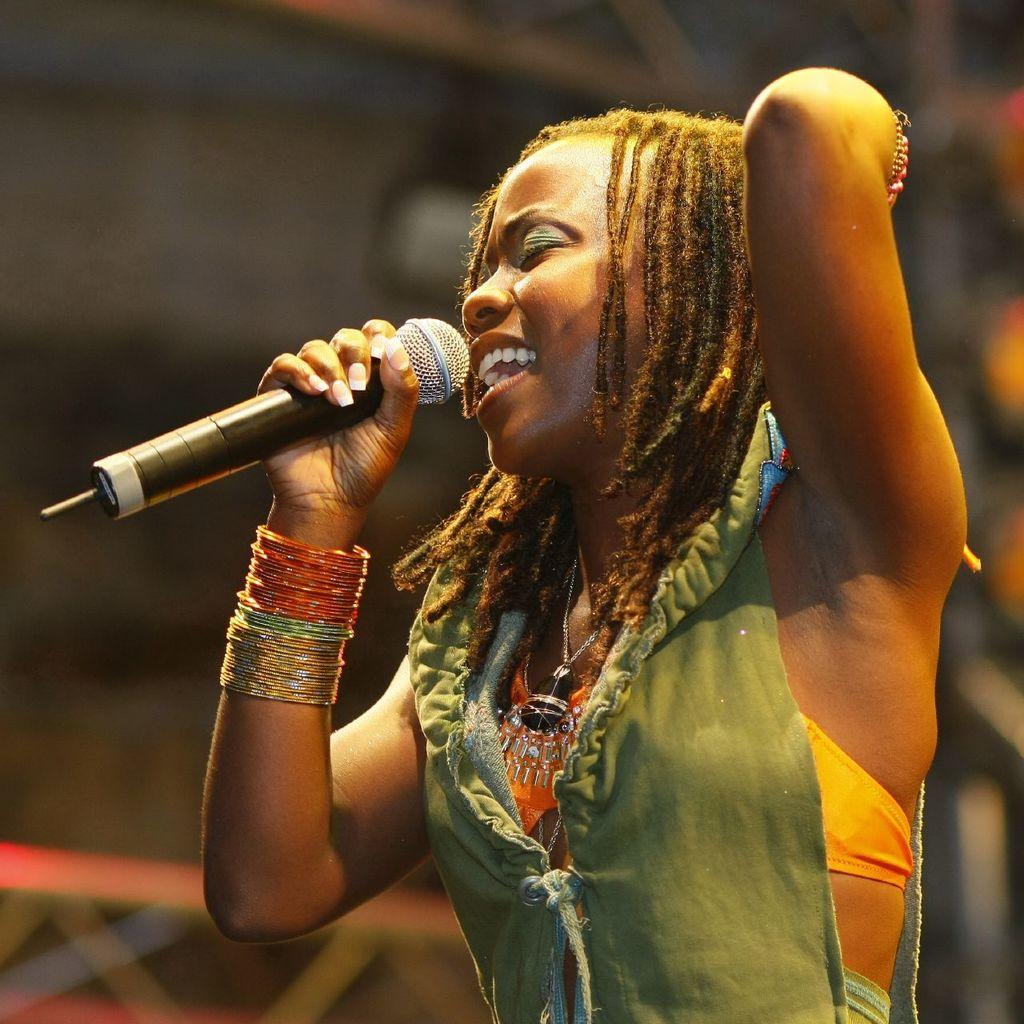Who is the main subject in the image? There is a lady in the center of the image. What is the lady doing in the image? The lady is singing. What object is the lady holding while singing? The lady is holding a microphone. What can be observed about the lady's mouth while she is singing? The lady's mouth is open. What type of bushes can be seen in the background of the image? There are no bushes visible in the image; it features a lady singing with a microphone. Is there a tray present in the image? There is no tray present in the image. 